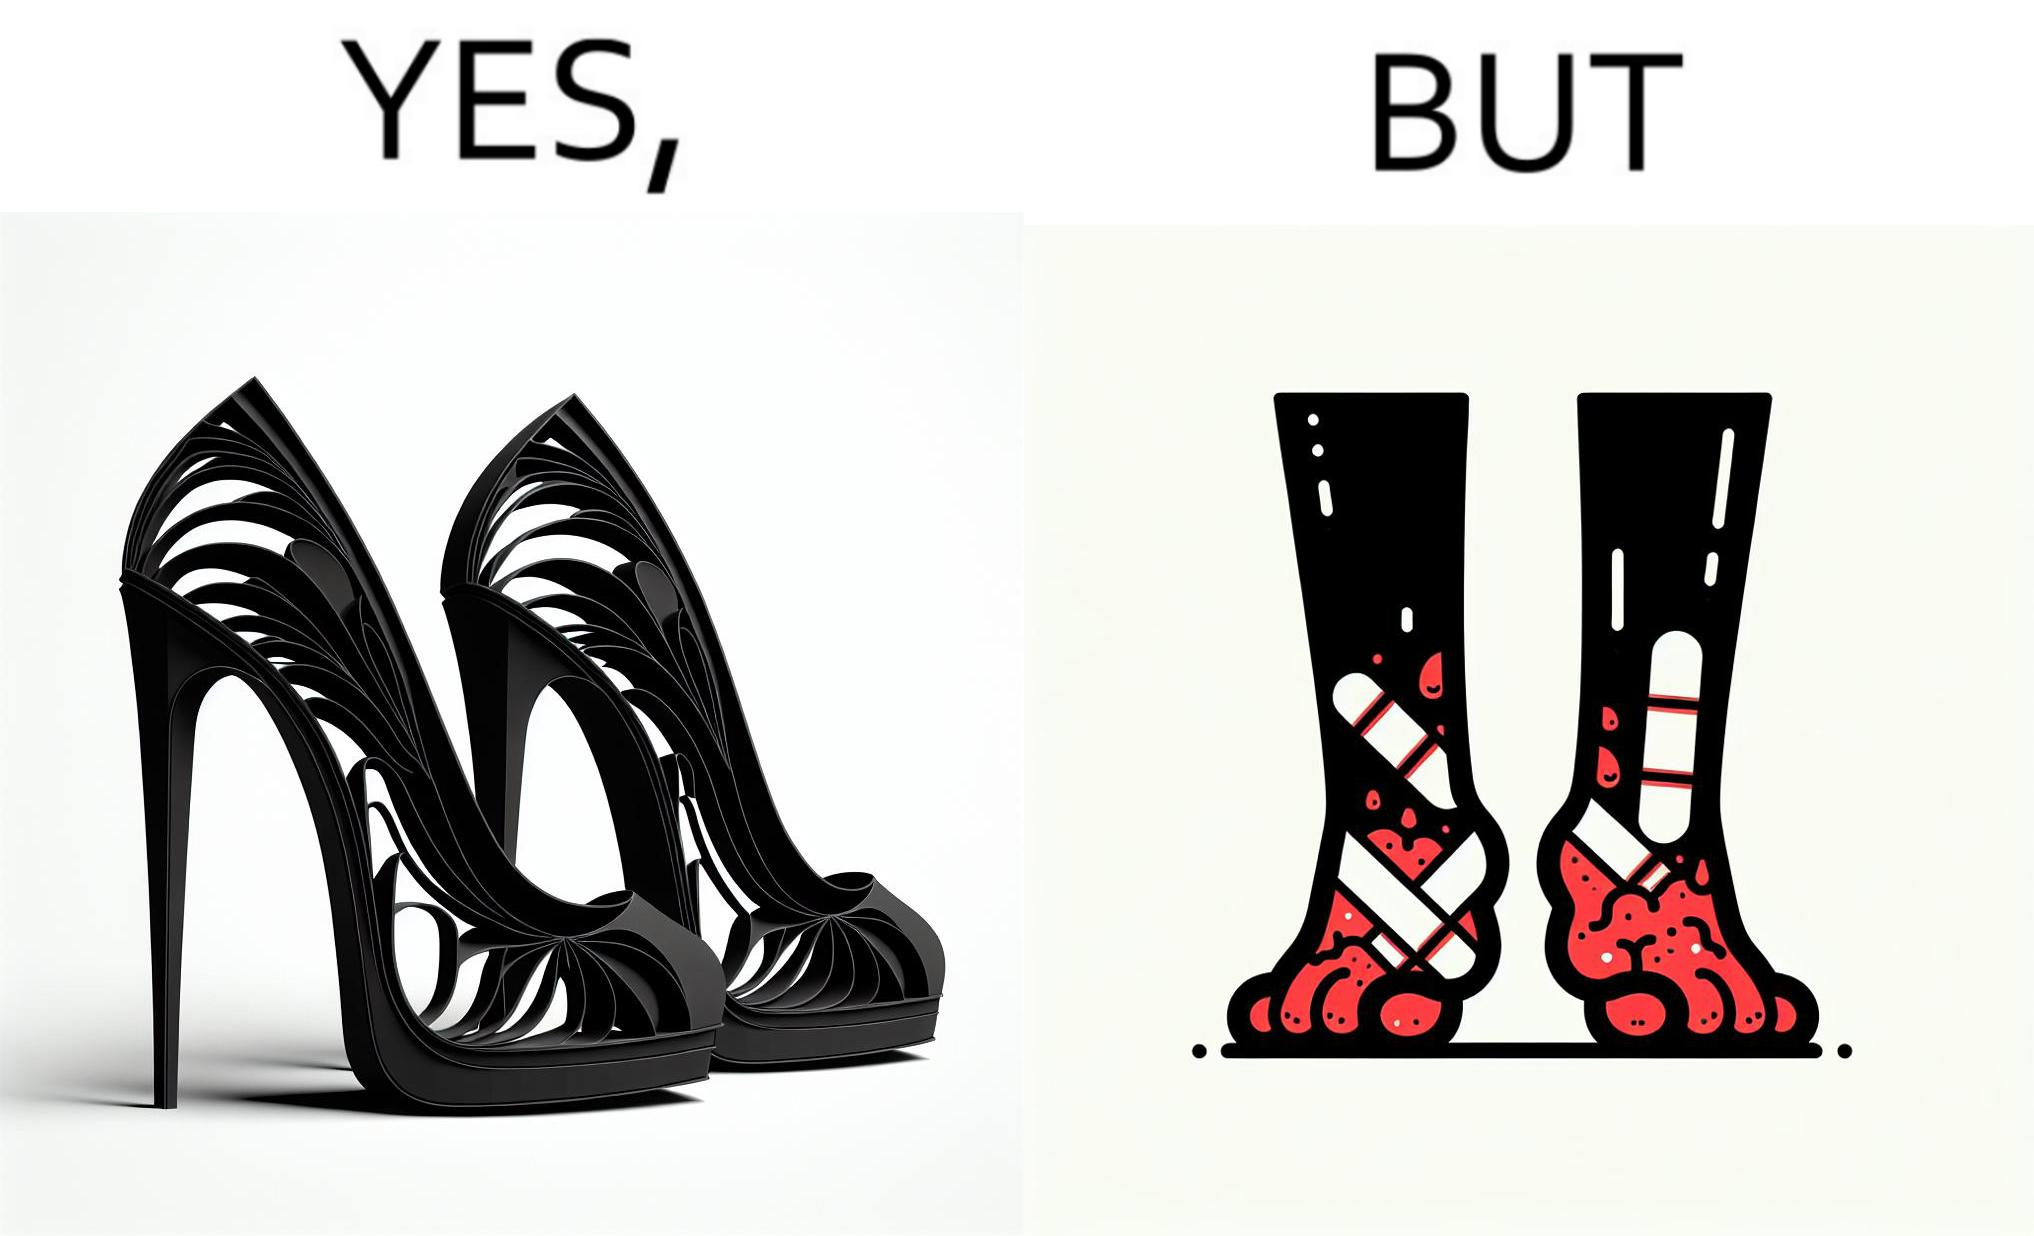What do you see in each half of this image? In the left part of the image: a pair of high heeled shoes In the right part of the image: A pair of feet, blistered and red, with bandages 